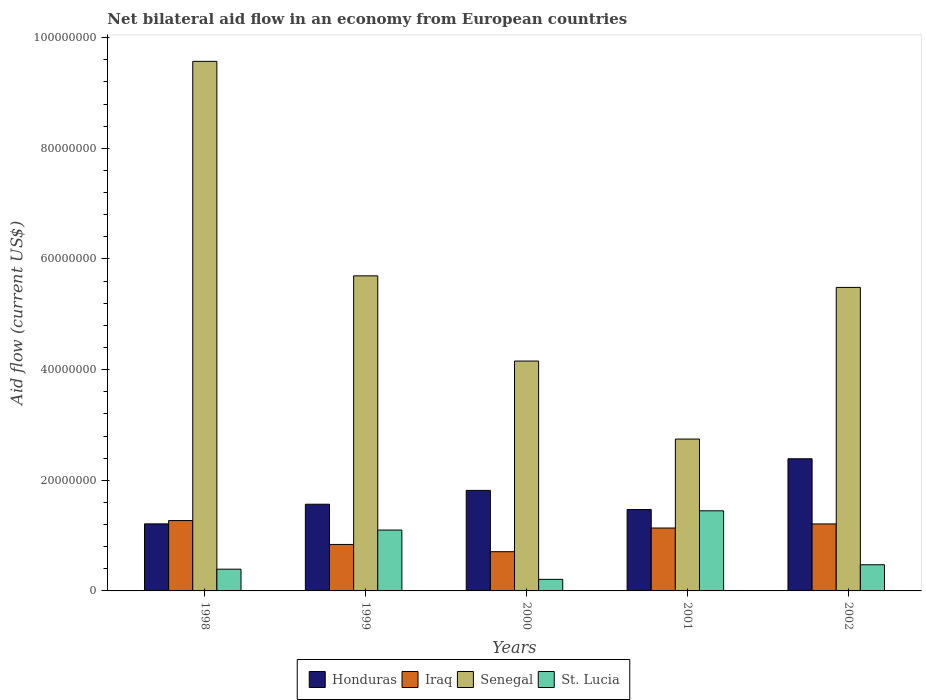How many different coloured bars are there?
Provide a succinct answer. 4. How many groups of bars are there?
Offer a terse response. 5. Are the number of bars per tick equal to the number of legend labels?
Offer a very short reply. Yes. Are the number of bars on each tick of the X-axis equal?
Your answer should be compact. Yes. How many bars are there on the 2nd tick from the left?
Your answer should be very brief. 4. How many bars are there on the 3rd tick from the right?
Your answer should be compact. 4. What is the label of the 2nd group of bars from the left?
Make the answer very short. 1999. What is the net bilateral aid flow in Honduras in 1998?
Provide a succinct answer. 1.21e+07. Across all years, what is the maximum net bilateral aid flow in Honduras?
Offer a very short reply. 2.39e+07. Across all years, what is the minimum net bilateral aid flow in Senegal?
Provide a succinct answer. 2.74e+07. In which year was the net bilateral aid flow in Honduras minimum?
Your answer should be very brief. 1998. What is the total net bilateral aid flow in Senegal in the graph?
Ensure brevity in your answer.  2.77e+08. What is the difference between the net bilateral aid flow in Honduras in 2000 and that in 2002?
Your answer should be very brief. -5.72e+06. What is the difference between the net bilateral aid flow in Honduras in 2000 and the net bilateral aid flow in St. Lucia in 1998?
Offer a terse response. 1.42e+07. What is the average net bilateral aid flow in Honduras per year?
Your response must be concise. 1.69e+07. In the year 2000, what is the difference between the net bilateral aid flow in Honduras and net bilateral aid flow in Iraq?
Ensure brevity in your answer.  1.11e+07. What is the ratio of the net bilateral aid flow in St. Lucia in 1998 to that in 2002?
Your response must be concise. 0.83. Is the net bilateral aid flow in St. Lucia in 2000 less than that in 2001?
Make the answer very short. Yes. What is the difference between the highest and the lowest net bilateral aid flow in Senegal?
Provide a succinct answer. 6.83e+07. Is the sum of the net bilateral aid flow in Honduras in 1999 and 2002 greater than the maximum net bilateral aid flow in Senegal across all years?
Keep it short and to the point. No. Is it the case that in every year, the sum of the net bilateral aid flow in St. Lucia and net bilateral aid flow in Senegal is greater than the sum of net bilateral aid flow in Iraq and net bilateral aid flow in Honduras?
Your response must be concise. Yes. What does the 3rd bar from the left in 2001 represents?
Offer a very short reply. Senegal. What does the 4th bar from the right in 1998 represents?
Give a very brief answer. Honduras. Is it the case that in every year, the sum of the net bilateral aid flow in St. Lucia and net bilateral aid flow in Honduras is greater than the net bilateral aid flow in Senegal?
Your answer should be compact. No. How many bars are there?
Offer a very short reply. 20. Are the values on the major ticks of Y-axis written in scientific E-notation?
Offer a terse response. No. Does the graph contain any zero values?
Make the answer very short. No. How many legend labels are there?
Give a very brief answer. 4. How are the legend labels stacked?
Ensure brevity in your answer.  Horizontal. What is the title of the graph?
Provide a succinct answer. Net bilateral aid flow in an economy from European countries. Does "Bulgaria" appear as one of the legend labels in the graph?
Your answer should be compact. No. What is the label or title of the Y-axis?
Your answer should be compact. Aid flow (current US$). What is the Aid flow (current US$) of Honduras in 1998?
Keep it short and to the point. 1.21e+07. What is the Aid flow (current US$) of Iraq in 1998?
Your response must be concise. 1.27e+07. What is the Aid flow (current US$) in Senegal in 1998?
Offer a terse response. 9.57e+07. What is the Aid flow (current US$) of St. Lucia in 1998?
Offer a terse response. 3.93e+06. What is the Aid flow (current US$) in Honduras in 1999?
Provide a short and direct response. 1.57e+07. What is the Aid flow (current US$) in Iraq in 1999?
Your answer should be very brief. 8.40e+06. What is the Aid flow (current US$) of Senegal in 1999?
Offer a terse response. 5.70e+07. What is the Aid flow (current US$) in St. Lucia in 1999?
Provide a succinct answer. 1.10e+07. What is the Aid flow (current US$) of Honduras in 2000?
Make the answer very short. 1.82e+07. What is the Aid flow (current US$) of Iraq in 2000?
Your answer should be very brief. 7.09e+06. What is the Aid flow (current US$) of Senegal in 2000?
Your response must be concise. 4.16e+07. What is the Aid flow (current US$) in St. Lucia in 2000?
Offer a terse response. 2.09e+06. What is the Aid flow (current US$) in Honduras in 2001?
Your answer should be compact. 1.47e+07. What is the Aid flow (current US$) in Iraq in 2001?
Your answer should be very brief. 1.14e+07. What is the Aid flow (current US$) of Senegal in 2001?
Offer a very short reply. 2.74e+07. What is the Aid flow (current US$) in St. Lucia in 2001?
Your response must be concise. 1.45e+07. What is the Aid flow (current US$) of Honduras in 2002?
Keep it short and to the point. 2.39e+07. What is the Aid flow (current US$) in Iraq in 2002?
Provide a succinct answer. 1.21e+07. What is the Aid flow (current US$) in Senegal in 2002?
Provide a short and direct response. 5.49e+07. What is the Aid flow (current US$) of St. Lucia in 2002?
Provide a short and direct response. 4.73e+06. Across all years, what is the maximum Aid flow (current US$) in Honduras?
Make the answer very short. 2.39e+07. Across all years, what is the maximum Aid flow (current US$) in Iraq?
Give a very brief answer. 1.27e+07. Across all years, what is the maximum Aid flow (current US$) in Senegal?
Provide a short and direct response. 9.57e+07. Across all years, what is the maximum Aid flow (current US$) in St. Lucia?
Offer a terse response. 1.45e+07. Across all years, what is the minimum Aid flow (current US$) in Honduras?
Make the answer very short. 1.21e+07. Across all years, what is the minimum Aid flow (current US$) in Iraq?
Offer a very short reply. 7.09e+06. Across all years, what is the minimum Aid flow (current US$) of Senegal?
Keep it short and to the point. 2.74e+07. Across all years, what is the minimum Aid flow (current US$) of St. Lucia?
Keep it short and to the point. 2.09e+06. What is the total Aid flow (current US$) in Honduras in the graph?
Provide a short and direct response. 8.46e+07. What is the total Aid flow (current US$) of Iraq in the graph?
Give a very brief answer. 5.17e+07. What is the total Aid flow (current US$) in Senegal in the graph?
Provide a short and direct response. 2.77e+08. What is the total Aid flow (current US$) of St. Lucia in the graph?
Keep it short and to the point. 3.62e+07. What is the difference between the Aid flow (current US$) in Honduras in 1998 and that in 1999?
Provide a short and direct response. -3.55e+06. What is the difference between the Aid flow (current US$) in Iraq in 1998 and that in 1999?
Make the answer very short. 4.32e+06. What is the difference between the Aid flow (current US$) in Senegal in 1998 and that in 1999?
Ensure brevity in your answer.  3.88e+07. What is the difference between the Aid flow (current US$) in St. Lucia in 1998 and that in 1999?
Offer a very short reply. -7.07e+06. What is the difference between the Aid flow (current US$) in Honduras in 1998 and that in 2000?
Your answer should be very brief. -6.05e+06. What is the difference between the Aid flow (current US$) of Iraq in 1998 and that in 2000?
Ensure brevity in your answer.  5.63e+06. What is the difference between the Aid flow (current US$) of Senegal in 1998 and that in 2000?
Keep it short and to the point. 5.42e+07. What is the difference between the Aid flow (current US$) in St. Lucia in 1998 and that in 2000?
Keep it short and to the point. 1.84e+06. What is the difference between the Aid flow (current US$) of Honduras in 1998 and that in 2001?
Make the answer very short. -2.59e+06. What is the difference between the Aid flow (current US$) in Iraq in 1998 and that in 2001?
Provide a succinct answer. 1.35e+06. What is the difference between the Aid flow (current US$) of Senegal in 1998 and that in 2001?
Offer a very short reply. 6.83e+07. What is the difference between the Aid flow (current US$) in St. Lucia in 1998 and that in 2001?
Ensure brevity in your answer.  -1.06e+07. What is the difference between the Aid flow (current US$) in Honduras in 1998 and that in 2002?
Keep it short and to the point. -1.18e+07. What is the difference between the Aid flow (current US$) in Iraq in 1998 and that in 2002?
Keep it short and to the point. 6.10e+05. What is the difference between the Aid flow (current US$) of Senegal in 1998 and that in 2002?
Your response must be concise. 4.09e+07. What is the difference between the Aid flow (current US$) of St. Lucia in 1998 and that in 2002?
Your response must be concise. -8.00e+05. What is the difference between the Aid flow (current US$) of Honduras in 1999 and that in 2000?
Your answer should be compact. -2.50e+06. What is the difference between the Aid flow (current US$) in Iraq in 1999 and that in 2000?
Make the answer very short. 1.31e+06. What is the difference between the Aid flow (current US$) of Senegal in 1999 and that in 2000?
Ensure brevity in your answer.  1.54e+07. What is the difference between the Aid flow (current US$) of St. Lucia in 1999 and that in 2000?
Your answer should be very brief. 8.91e+06. What is the difference between the Aid flow (current US$) in Honduras in 1999 and that in 2001?
Make the answer very short. 9.60e+05. What is the difference between the Aid flow (current US$) of Iraq in 1999 and that in 2001?
Keep it short and to the point. -2.97e+06. What is the difference between the Aid flow (current US$) of Senegal in 1999 and that in 2001?
Ensure brevity in your answer.  2.95e+07. What is the difference between the Aid flow (current US$) in St. Lucia in 1999 and that in 2001?
Offer a very short reply. -3.48e+06. What is the difference between the Aid flow (current US$) of Honduras in 1999 and that in 2002?
Provide a succinct answer. -8.22e+06. What is the difference between the Aid flow (current US$) in Iraq in 1999 and that in 2002?
Offer a terse response. -3.71e+06. What is the difference between the Aid flow (current US$) of Senegal in 1999 and that in 2002?
Your answer should be compact. 2.09e+06. What is the difference between the Aid flow (current US$) of St. Lucia in 1999 and that in 2002?
Provide a short and direct response. 6.27e+06. What is the difference between the Aid flow (current US$) in Honduras in 2000 and that in 2001?
Offer a very short reply. 3.46e+06. What is the difference between the Aid flow (current US$) of Iraq in 2000 and that in 2001?
Your answer should be compact. -4.28e+06. What is the difference between the Aid flow (current US$) of Senegal in 2000 and that in 2001?
Give a very brief answer. 1.41e+07. What is the difference between the Aid flow (current US$) of St. Lucia in 2000 and that in 2001?
Your response must be concise. -1.24e+07. What is the difference between the Aid flow (current US$) of Honduras in 2000 and that in 2002?
Your response must be concise. -5.72e+06. What is the difference between the Aid flow (current US$) in Iraq in 2000 and that in 2002?
Provide a short and direct response. -5.02e+06. What is the difference between the Aid flow (current US$) of Senegal in 2000 and that in 2002?
Give a very brief answer. -1.33e+07. What is the difference between the Aid flow (current US$) in St. Lucia in 2000 and that in 2002?
Offer a terse response. -2.64e+06. What is the difference between the Aid flow (current US$) in Honduras in 2001 and that in 2002?
Ensure brevity in your answer.  -9.18e+06. What is the difference between the Aid flow (current US$) in Iraq in 2001 and that in 2002?
Make the answer very short. -7.40e+05. What is the difference between the Aid flow (current US$) in Senegal in 2001 and that in 2002?
Give a very brief answer. -2.74e+07. What is the difference between the Aid flow (current US$) of St. Lucia in 2001 and that in 2002?
Provide a short and direct response. 9.75e+06. What is the difference between the Aid flow (current US$) in Honduras in 1998 and the Aid flow (current US$) in Iraq in 1999?
Provide a succinct answer. 3.72e+06. What is the difference between the Aid flow (current US$) in Honduras in 1998 and the Aid flow (current US$) in Senegal in 1999?
Provide a succinct answer. -4.48e+07. What is the difference between the Aid flow (current US$) in Honduras in 1998 and the Aid flow (current US$) in St. Lucia in 1999?
Give a very brief answer. 1.12e+06. What is the difference between the Aid flow (current US$) of Iraq in 1998 and the Aid flow (current US$) of Senegal in 1999?
Keep it short and to the point. -4.42e+07. What is the difference between the Aid flow (current US$) of Iraq in 1998 and the Aid flow (current US$) of St. Lucia in 1999?
Ensure brevity in your answer.  1.72e+06. What is the difference between the Aid flow (current US$) of Senegal in 1998 and the Aid flow (current US$) of St. Lucia in 1999?
Give a very brief answer. 8.47e+07. What is the difference between the Aid flow (current US$) in Honduras in 1998 and the Aid flow (current US$) in Iraq in 2000?
Ensure brevity in your answer.  5.03e+06. What is the difference between the Aid flow (current US$) of Honduras in 1998 and the Aid flow (current US$) of Senegal in 2000?
Give a very brief answer. -2.94e+07. What is the difference between the Aid flow (current US$) of Honduras in 1998 and the Aid flow (current US$) of St. Lucia in 2000?
Make the answer very short. 1.00e+07. What is the difference between the Aid flow (current US$) of Iraq in 1998 and the Aid flow (current US$) of Senegal in 2000?
Give a very brief answer. -2.88e+07. What is the difference between the Aid flow (current US$) of Iraq in 1998 and the Aid flow (current US$) of St. Lucia in 2000?
Provide a short and direct response. 1.06e+07. What is the difference between the Aid flow (current US$) in Senegal in 1998 and the Aid flow (current US$) in St. Lucia in 2000?
Your response must be concise. 9.36e+07. What is the difference between the Aid flow (current US$) in Honduras in 1998 and the Aid flow (current US$) in Iraq in 2001?
Make the answer very short. 7.50e+05. What is the difference between the Aid flow (current US$) of Honduras in 1998 and the Aid flow (current US$) of Senegal in 2001?
Ensure brevity in your answer.  -1.53e+07. What is the difference between the Aid flow (current US$) in Honduras in 1998 and the Aid flow (current US$) in St. Lucia in 2001?
Offer a terse response. -2.36e+06. What is the difference between the Aid flow (current US$) in Iraq in 1998 and the Aid flow (current US$) in Senegal in 2001?
Give a very brief answer. -1.47e+07. What is the difference between the Aid flow (current US$) of Iraq in 1998 and the Aid flow (current US$) of St. Lucia in 2001?
Your response must be concise. -1.76e+06. What is the difference between the Aid flow (current US$) in Senegal in 1998 and the Aid flow (current US$) in St. Lucia in 2001?
Ensure brevity in your answer.  8.12e+07. What is the difference between the Aid flow (current US$) in Honduras in 1998 and the Aid flow (current US$) in Senegal in 2002?
Your answer should be compact. -4.27e+07. What is the difference between the Aid flow (current US$) of Honduras in 1998 and the Aid flow (current US$) of St. Lucia in 2002?
Give a very brief answer. 7.39e+06. What is the difference between the Aid flow (current US$) in Iraq in 1998 and the Aid flow (current US$) in Senegal in 2002?
Make the answer very short. -4.21e+07. What is the difference between the Aid flow (current US$) of Iraq in 1998 and the Aid flow (current US$) of St. Lucia in 2002?
Your answer should be compact. 7.99e+06. What is the difference between the Aid flow (current US$) of Senegal in 1998 and the Aid flow (current US$) of St. Lucia in 2002?
Your response must be concise. 9.10e+07. What is the difference between the Aid flow (current US$) in Honduras in 1999 and the Aid flow (current US$) in Iraq in 2000?
Provide a short and direct response. 8.58e+06. What is the difference between the Aid flow (current US$) in Honduras in 1999 and the Aid flow (current US$) in Senegal in 2000?
Your answer should be very brief. -2.59e+07. What is the difference between the Aid flow (current US$) in Honduras in 1999 and the Aid flow (current US$) in St. Lucia in 2000?
Your answer should be very brief. 1.36e+07. What is the difference between the Aid flow (current US$) of Iraq in 1999 and the Aid flow (current US$) of Senegal in 2000?
Give a very brief answer. -3.32e+07. What is the difference between the Aid flow (current US$) in Iraq in 1999 and the Aid flow (current US$) in St. Lucia in 2000?
Provide a succinct answer. 6.31e+06. What is the difference between the Aid flow (current US$) of Senegal in 1999 and the Aid flow (current US$) of St. Lucia in 2000?
Your answer should be very brief. 5.49e+07. What is the difference between the Aid flow (current US$) of Honduras in 1999 and the Aid flow (current US$) of Iraq in 2001?
Keep it short and to the point. 4.30e+06. What is the difference between the Aid flow (current US$) in Honduras in 1999 and the Aid flow (current US$) in Senegal in 2001?
Provide a succinct answer. -1.18e+07. What is the difference between the Aid flow (current US$) of Honduras in 1999 and the Aid flow (current US$) of St. Lucia in 2001?
Offer a terse response. 1.19e+06. What is the difference between the Aid flow (current US$) of Iraq in 1999 and the Aid flow (current US$) of Senegal in 2001?
Give a very brief answer. -1.90e+07. What is the difference between the Aid flow (current US$) of Iraq in 1999 and the Aid flow (current US$) of St. Lucia in 2001?
Ensure brevity in your answer.  -6.08e+06. What is the difference between the Aid flow (current US$) of Senegal in 1999 and the Aid flow (current US$) of St. Lucia in 2001?
Your response must be concise. 4.25e+07. What is the difference between the Aid flow (current US$) in Honduras in 1999 and the Aid flow (current US$) in Iraq in 2002?
Your answer should be very brief. 3.56e+06. What is the difference between the Aid flow (current US$) of Honduras in 1999 and the Aid flow (current US$) of Senegal in 2002?
Provide a short and direct response. -3.92e+07. What is the difference between the Aid flow (current US$) in Honduras in 1999 and the Aid flow (current US$) in St. Lucia in 2002?
Your response must be concise. 1.09e+07. What is the difference between the Aid flow (current US$) in Iraq in 1999 and the Aid flow (current US$) in Senegal in 2002?
Your response must be concise. -4.65e+07. What is the difference between the Aid flow (current US$) in Iraq in 1999 and the Aid flow (current US$) in St. Lucia in 2002?
Give a very brief answer. 3.67e+06. What is the difference between the Aid flow (current US$) in Senegal in 1999 and the Aid flow (current US$) in St. Lucia in 2002?
Provide a succinct answer. 5.22e+07. What is the difference between the Aid flow (current US$) in Honduras in 2000 and the Aid flow (current US$) in Iraq in 2001?
Make the answer very short. 6.80e+06. What is the difference between the Aid flow (current US$) in Honduras in 2000 and the Aid flow (current US$) in Senegal in 2001?
Ensure brevity in your answer.  -9.28e+06. What is the difference between the Aid flow (current US$) of Honduras in 2000 and the Aid flow (current US$) of St. Lucia in 2001?
Keep it short and to the point. 3.69e+06. What is the difference between the Aid flow (current US$) in Iraq in 2000 and the Aid flow (current US$) in Senegal in 2001?
Keep it short and to the point. -2.04e+07. What is the difference between the Aid flow (current US$) in Iraq in 2000 and the Aid flow (current US$) in St. Lucia in 2001?
Ensure brevity in your answer.  -7.39e+06. What is the difference between the Aid flow (current US$) in Senegal in 2000 and the Aid flow (current US$) in St. Lucia in 2001?
Your answer should be very brief. 2.71e+07. What is the difference between the Aid flow (current US$) of Honduras in 2000 and the Aid flow (current US$) of Iraq in 2002?
Offer a terse response. 6.06e+06. What is the difference between the Aid flow (current US$) of Honduras in 2000 and the Aid flow (current US$) of Senegal in 2002?
Offer a terse response. -3.67e+07. What is the difference between the Aid flow (current US$) in Honduras in 2000 and the Aid flow (current US$) in St. Lucia in 2002?
Make the answer very short. 1.34e+07. What is the difference between the Aid flow (current US$) in Iraq in 2000 and the Aid flow (current US$) in Senegal in 2002?
Make the answer very short. -4.78e+07. What is the difference between the Aid flow (current US$) of Iraq in 2000 and the Aid flow (current US$) of St. Lucia in 2002?
Provide a succinct answer. 2.36e+06. What is the difference between the Aid flow (current US$) of Senegal in 2000 and the Aid flow (current US$) of St. Lucia in 2002?
Your answer should be very brief. 3.68e+07. What is the difference between the Aid flow (current US$) in Honduras in 2001 and the Aid flow (current US$) in Iraq in 2002?
Your answer should be compact. 2.60e+06. What is the difference between the Aid flow (current US$) of Honduras in 2001 and the Aid flow (current US$) of Senegal in 2002?
Offer a terse response. -4.02e+07. What is the difference between the Aid flow (current US$) of Honduras in 2001 and the Aid flow (current US$) of St. Lucia in 2002?
Keep it short and to the point. 9.98e+06. What is the difference between the Aid flow (current US$) in Iraq in 2001 and the Aid flow (current US$) in Senegal in 2002?
Your answer should be very brief. -4.35e+07. What is the difference between the Aid flow (current US$) in Iraq in 2001 and the Aid flow (current US$) in St. Lucia in 2002?
Provide a succinct answer. 6.64e+06. What is the difference between the Aid flow (current US$) in Senegal in 2001 and the Aid flow (current US$) in St. Lucia in 2002?
Your answer should be compact. 2.27e+07. What is the average Aid flow (current US$) of Honduras per year?
Offer a terse response. 1.69e+07. What is the average Aid flow (current US$) of Iraq per year?
Offer a very short reply. 1.03e+07. What is the average Aid flow (current US$) of Senegal per year?
Offer a terse response. 5.53e+07. What is the average Aid flow (current US$) of St. Lucia per year?
Ensure brevity in your answer.  7.25e+06. In the year 1998, what is the difference between the Aid flow (current US$) in Honduras and Aid flow (current US$) in Iraq?
Make the answer very short. -6.00e+05. In the year 1998, what is the difference between the Aid flow (current US$) in Honduras and Aid flow (current US$) in Senegal?
Give a very brief answer. -8.36e+07. In the year 1998, what is the difference between the Aid flow (current US$) in Honduras and Aid flow (current US$) in St. Lucia?
Make the answer very short. 8.19e+06. In the year 1998, what is the difference between the Aid flow (current US$) of Iraq and Aid flow (current US$) of Senegal?
Your answer should be very brief. -8.30e+07. In the year 1998, what is the difference between the Aid flow (current US$) of Iraq and Aid flow (current US$) of St. Lucia?
Offer a very short reply. 8.79e+06. In the year 1998, what is the difference between the Aid flow (current US$) of Senegal and Aid flow (current US$) of St. Lucia?
Make the answer very short. 9.18e+07. In the year 1999, what is the difference between the Aid flow (current US$) in Honduras and Aid flow (current US$) in Iraq?
Your answer should be very brief. 7.27e+06. In the year 1999, what is the difference between the Aid flow (current US$) of Honduras and Aid flow (current US$) of Senegal?
Your answer should be very brief. -4.13e+07. In the year 1999, what is the difference between the Aid flow (current US$) in Honduras and Aid flow (current US$) in St. Lucia?
Offer a very short reply. 4.67e+06. In the year 1999, what is the difference between the Aid flow (current US$) in Iraq and Aid flow (current US$) in Senegal?
Your answer should be very brief. -4.86e+07. In the year 1999, what is the difference between the Aid flow (current US$) in Iraq and Aid flow (current US$) in St. Lucia?
Make the answer very short. -2.60e+06. In the year 1999, what is the difference between the Aid flow (current US$) of Senegal and Aid flow (current US$) of St. Lucia?
Provide a succinct answer. 4.60e+07. In the year 2000, what is the difference between the Aid flow (current US$) of Honduras and Aid flow (current US$) of Iraq?
Offer a very short reply. 1.11e+07. In the year 2000, what is the difference between the Aid flow (current US$) in Honduras and Aid flow (current US$) in Senegal?
Ensure brevity in your answer.  -2.34e+07. In the year 2000, what is the difference between the Aid flow (current US$) of Honduras and Aid flow (current US$) of St. Lucia?
Make the answer very short. 1.61e+07. In the year 2000, what is the difference between the Aid flow (current US$) in Iraq and Aid flow (current US$) in Senegal?
Provide a succinct answer. -3.45e+07. In the year 2000, what is the difference between the Aid flow (current US$) in Iraq and Aid flow (current US$) in St. Lucia?
Provide a short and direct response. 5.00e+06. In the year 2000, what is the difference between the Aid flow (current US$) of Senegal and Aid flow (current US$) of St. Lucia?
Offer a terse response. 3.95e+07. In the year 2001, what is the difference between the Aid flow (current US$) in Honduras and Aid flow (current US$) in Iraq?
Ensure brevity in your answer.  3.34e+06. In the year 2001, what is the difference between the Aid flow (current US$) in Honduras and Aid flow (current US$) in Senegal?
Your response must be concise. -1.27e+07. In the year 2001, what is the difference between the Aid flow (current US$) of Honduras and Aid flow (current US$) of St. Lucia?
Offer a very short reply. 2.30e+05. In the year 2001, what is the difference between the Aid flow (current US$) in Iraq and Aid flow (current US$) in Senegal?
Your answer should be compact. -1.61e+07. In the year 2001, what is the difference between the Aid flow (current US$) in Iraq and Aid flow (current US$) in St. Lucia?
Provide a short and direct response. -3.11e+06. In the year 2001, what is the difference between the Aid flow (current US$) in Senegal and Aid flow (current US$) in St. Lucia?
Your answer should be very brief. 1.30e+07. In the year 2002, what is the difference between the Aid flow (current US$) in Honduras and Aid flow (current US$) in Iraq?
Keep it short and to the point. 1.18e+07. In the year 2002, what is the difference between the Aid flow (current US$) in Honduras and Aid flow (current US$) in Senegal?
Give a very brief answer. -3.10e+07. In the year 2002, what is the difference between the Aid flow (current US$) of Honduras and Aid flow (current US$) of St. Lucia?
Provide a short and direct response. 1.92e+07. In the year 2002, what is the difference between the Aid flow (current US$) of Iraq and Aid flow (current US$) of Senegal?
Offer a very short reply. -4.28e+07. In the year 2002, what is the difference between the Aid flow (current US$) of Iraq and Aid flow (current US$) of St. Lucia?
Provide a succinct answer. 7.38e+06. In the year 2002, what is the difference between the Aid flow (current US$) of Senegal and Aid flow (current US$) of St. Lucia?
Give a very brief answer. 5.01e+07. What is the ratio of the Aid flow (current US$) of Honduras in 1998 to that in 1999?
Give a very brief answer. 0.77. What is the ratio of the Aid flow (current US$) of Iraq in 1998 to that in 1999?
Provide a succinct answer. 1.51. What is the ratio of the Aid flow (current US$) of Senegal in 1998 to that in 1999?
Your response must be concise. 1.68. What is the ratio of the Aid flow (current US$) in St. Lucia in 1998 to that in 1999?
Provide a succinct answer. 0.36. What is the ratio of the Aid flow (current US$) of Honduras in 1998 to that in 2000?
Your response must be concise. 0.67. What is the ratio of the Aid flow (current US$) in Iraq in 1998 to that in 2000?
Keep it short and to the point. 1.79. What is the ratio of the Aid flow (current US$) in Senegal in 1998 to that in 2000?
Make the answer very short. 2.3. What is the ratio of the Aid flow (current US$) of St. Lucia in 1998 to that in 2000?
Offer a terse response. 1.88. What is the ratio of the Aid flow (current US$) of Honduras in 1998 to that in 2001?
Give a very brief answer. 0.82. What is the ratio of the Aid flow (current US$) in Iraq in 1998 to that in 2001?
Your answer should be compact. 1.12. What is the ratio of the Aid flow (current US$) in Senegal in 1998 to that in 2001?
Offer a very short reply. 3.49. What is the ratio of the Aid flow (current US$) of St. Lucia in 1998 to that in 2001?
Provide a succinct answer. 0.27. What is the ratio of the Aid flow (current US$) of Honduras in 1998 to that in 2002?
Give a very brief answer. 0.51. What is the ratio of the Aid flow (current US$) of Iraq in 1998 to that in 2002?
Your response must be concise. 1.05. What is the ratio of the Aid flow (current US$) in Senegal in 1998 to that in 2002?
Keep it short and to the point. 1.74. What is the ratio of the Aid flow (current US$) in St. Lucia in 1998 to that in 2002?
Your answer should be very brief. 0.83. What is the ratio of the Aid flow (current US$) of Honduras in 1999 to that in 2000?
Provide a succinct answer. 0.86. What is the ratio of the Aid flow (current US$) of Iraq in 1999 to that in 2000?
Keep it short and to the point. 1.18. What is the ratio of the Aid flow (current US$) in Senegal in 1999 to that in 2000?
Ensure brevity in your answer.  1.37. What is the ratio of the Aid flow (current US$) in St. Lucia in 1999 to that in 2000?
Offer a very short reply. 5.26. What is the ratio of the Aid flow (current US$) in Honduras in 1999 to that in 2001?
Make the answer very short. 1.07. What is the ratio of the Aid flow (current US$) of Iraq in 1999 to that in 2001?
Provide a succinct answer. 0.74. What is the ratio of the Aid flow (current US$) of Senegal in 1999 to that in 2001?
Your answer should be compact. 2.07. What is the ratio of the Aid flow (current US$) of St. Lucia in 1999 to that in 2001?
Ensure brevity in your answer.  0.76. What is the ratio of the Aid flow (current US$) of Honduras in 1999 to that in 2002?
Your answer should be very brief. 0.66. What is the ratio of the Aid flow (current US$) in Iraq in 1999 to that in 2002?
Offer a terse response. 0.69. What is the ratio of the Aid flow (current US$) of Senegal in 1999 to that in 2002?
Keep it short and to the point. 1.04. What is the ratio of the Aid flow (current US$) in St. Lucia in 1999 to that in 2002?
Your answer should be compact. 2.33. What is the ratio of the Aid flow (current US$) in Honduras in 2000 to that in 2001?
Your answer should be very brief. 1.24. What is the ratio of the Aid flow (current US$) of Iraq in 2000 to that in 2001?
Your response must be concise. 0.62. What is the ratio of the Aid flow (current US$) in Senegal in 2000 to that in 2001?
Make the answer very short. 1.51. What is the ratio of the Aid flow (current US$) in St. Lucia in 2000 to that in 2001?
Give a very brief answer. 0.14. What is the ratio of the Aid flow (current US$) in Honduras in 2000 to that in 2002?
Give a very brief answer. 0.76. What is the ratio of the Aid flow (current US$) in Iraq in 2000 to that in 2002?
Provide a succinct answer. 0.59. What is the ratio of the Aid flow (current US$) in Senegal in 2000 to that in 2002?
Provide a short and direct response. 0.76. What is the ratio of the Aid flow (current US$) of St. Lucia in 2000 to that in 2002?
Your response must be concise. 0.44. What is the ratio of the Aid flow (current US$) in Honduras in 2001 to that in 2002?
Offer a very short reply. 0.62. What is the ratio of the Aid flow (current US$) of Iraq in 2001 to that in 2002?
Give a very brief answer. 0.94. What is the ratio of the Aid flow (current US$) in Senegal in 2001 to that in 2002?
Your response must be concise. 0.5. What is the ratio of the Aid flow (current US$) of St. Lucia in 2001 to that in 2002?
Offer a very short reply. 3.06. What is the difference between the highest and the second highest Aid flow (current US$) of Honduras?
Keep it short and to the point. 5.72e+06. What is the difference between the highest and the second highest Aid flow (current US$) of Iraq?
Your answer should be very brief. 6.10e+05. What is the difference between the highest and the second highest Aid flow (current US$) in Senegal?
Give a very brief answer. 3.88e+07. What is the difference between the highest and the second highest Aid flow (current US$) in St. Lucia?
Offer a terse response. 3.48e+06. What is the difference between the highest and the lowest Aid flow (current US$) of Honduras?
Offer a very short reply. 1.18e+07. What is the difference between the highest and the lowest Aid flow (current US$) of Iraq?
Offer a terse response. 5.63e+06. What is the difference between the highest and the lowest Aid flow (current US$) of Senegal?
Keep it short and to the point. 6.83e+07. What is the difference between the highest and the lowest Aid flow (current US$) of St. Lucia?
Offer a very short reply. 1.24e+07. 